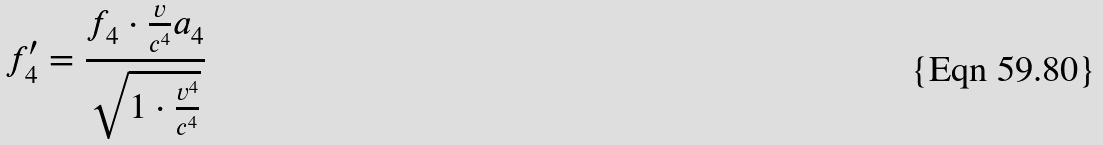Convert formula to latex. <formula><loc_0><loc_0><loc_500><loc_500>f _ { 4 } ^ { \prime } = \frac { f _ { 4 } \cdot \frac { v } { c ^ { 4 } } a _ { 4 } } { \sqrt { 1 \cdot \frac { v ^ { 4 } } { c ^ { 4 } } } }</formula> 